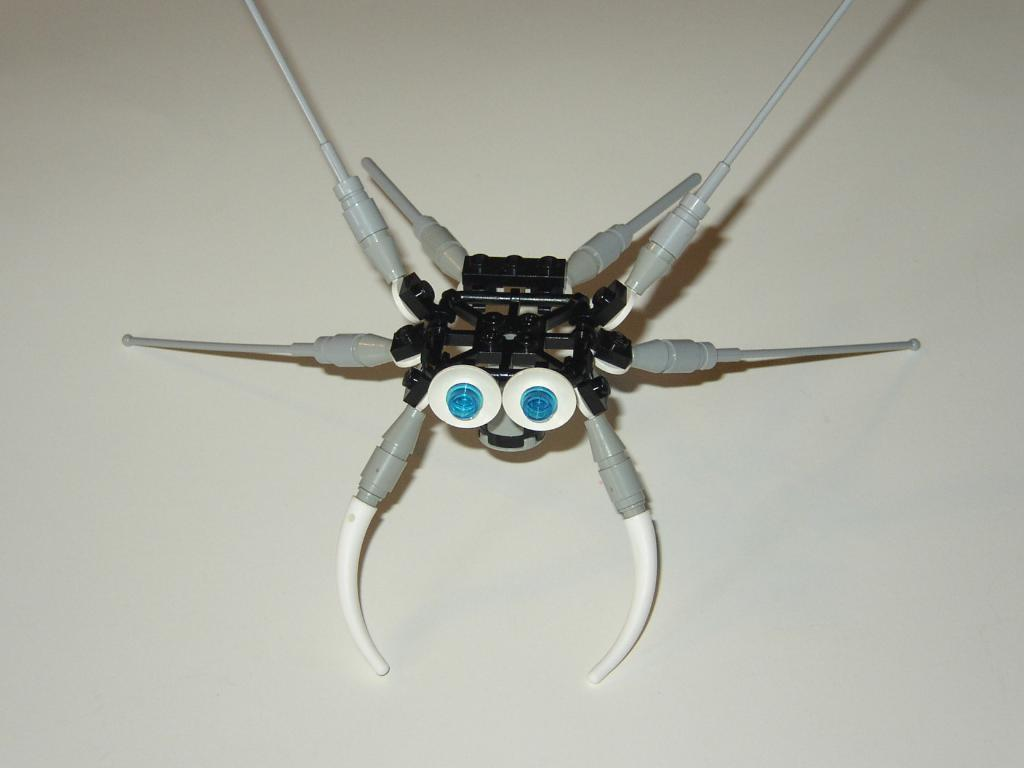What type of toy is in the picture? There is a toy spider in the picture. What features does the toy spider have? The toy spider has eyes and legs. What type of dog can be seen playing with the toy spider in the image? There is no dog present in the image; it only features a toy spider. What scientific experiment is being conducted with the toy spider in the image? There is no scientific experiment depicted in the image; it simply shows a toy spider with eyes and legs. 